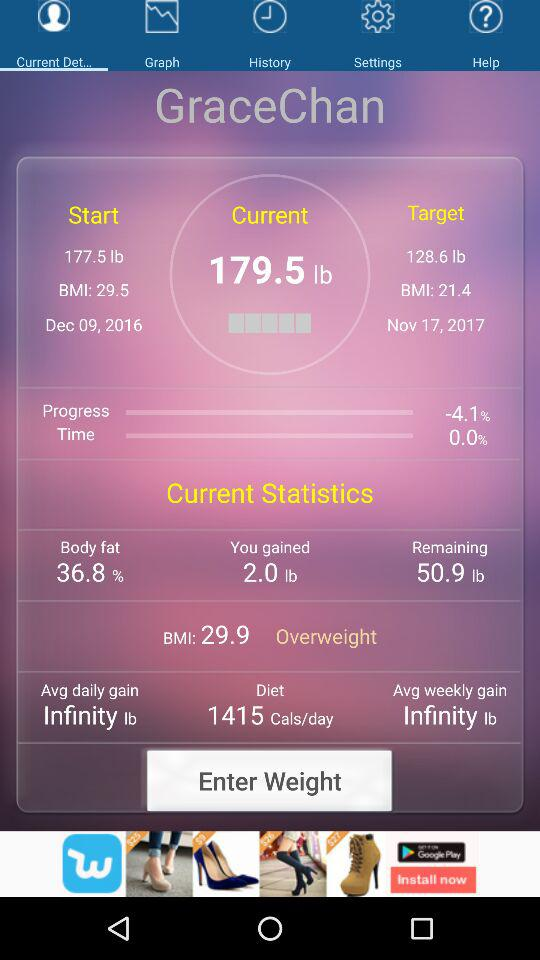What is the start date? The start date is December 9, 2016. 